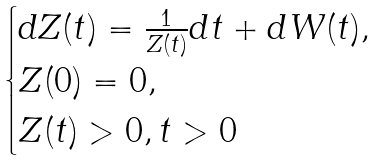<formula> <loc_0><loc_0><loc_500><loc_500>\begin{cases} d Z ( t ) = \frac { 1 } { Z ( t ) } d t + d W ( t ) , \\ Z ( 0 ) = 0 , \\ Z ( t ) > 0 , t > 0 \end{cases}</formula> 